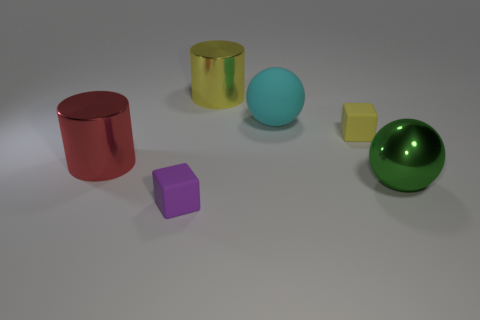Add 2 brown metal objects. How many objects exist? 8 Subtract all cylinders. How many objects are left? 4 Subtract all yellow matte cubes. Subtract all small brown metal spheres. How many objects are left? 5 Add 3 green shiny objects. How many green shiny objects are left? 4 Add 5 small matte blocks. How many small matte blocks exist? 7 Subtract 0 blue cubes. How many objects are left? 6 